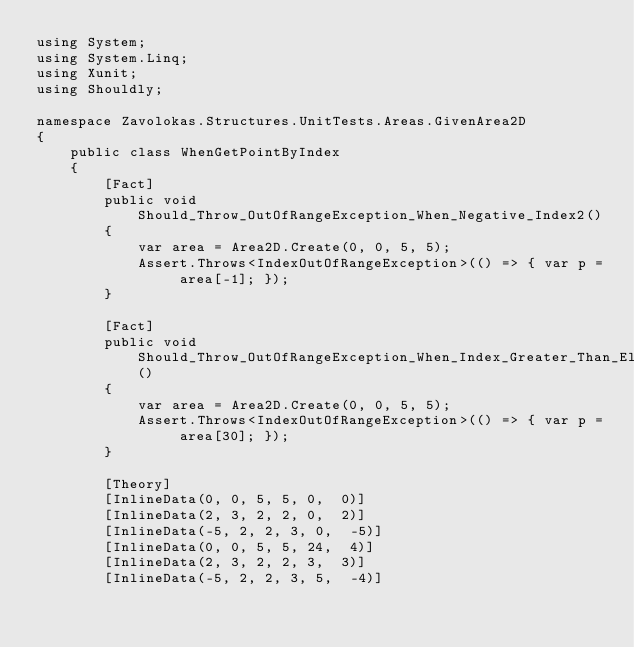<code> <loc_0><loc_0><loc_500><loc_500><_C#_>using System;
using System.Linq;
using Xunit;
using Shouldly;

namespace Zavolokas.Structures.UnitTests.Areas.GivenArea2D
{
    public class WhenGetPointByIndex
    {
        [Fact]
        public void Should_Throw_OutOfRangeException_When_Negative_Index2()
        {
            var area = Area2D.Create(0, 0, 5, 5);
            Assert.Throws<IndexOutOfRangeException>(() => { var p = area[-1]; });
        }

        [Fact]
        public void Should_Throw_OutOfRangeException_When_Index_Greater_Than_ElementsCount2()
        {
            var area = Area2D.Create(0, 0, 5, 5);
            Assert.Throws<IndexOutOfRangeException>(() => { var p = area[30]; });
        }

        [Theory]
        [InlineData(0, 0, 5, 5, 0,  0)]
        [InlineData(2, 3, 2, 2, 0,  2)]
        [InlineData(-5, 2, 2, 3, 0,  -5)]
        [InlineData(0, 0, 5, 5, 24,  4)]
        [InlineData(2, 3, 2, 2, 3,  3)]
        [InlineData(-5, 2, 2, 3, 5,  -4)]</code> 